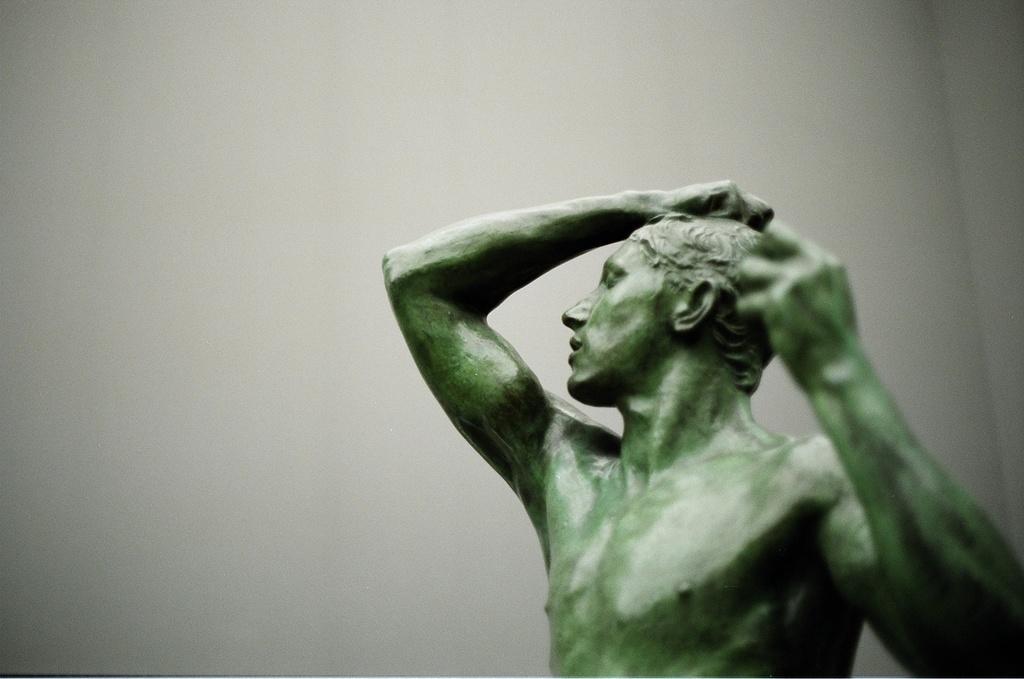Describe this image in one or two sentences. In this image there is a sculpture of a man towards the bottom of the image, at the background of the image there is a wall, the background of the image is white in color. 